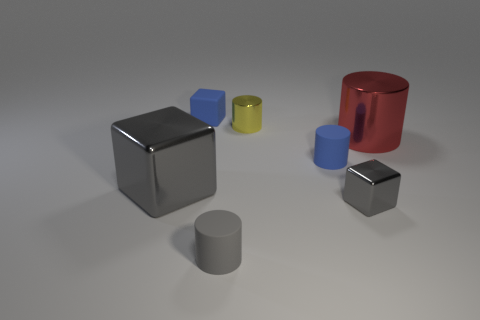What number of other things are the same color as the big shiny cylinder?
Offer a very short reply. 0. Are there fewer tiny gray cubes than large cyan cylinders?
Provide a short and direct response. No. What shape is the tiny blue object in front of the tiny blue object behind the large cylinder?
Ensure brevity in your answer.  Cylinder. Are there any tiny cylinders behind the gray rubber cylinder?
Keep it short and to the point. Yes. There is a matte block that is the same size as the gray rubber cylinder; what color is it?
Your answer should be compact. Blue. How many red things are made of the same material as the blue block?
Your answer should be compact. 0. How many other objects are the same size as the yellow shiny cylinder?
Your response must be concise. 4. Are there any gray shiny objects of the same size as the red object?
Your answer should be very brief. Yes. Is the color of the large shiny object that is to the left of the tiny metal cube the same as the tiny shiny block?
Provide a succinct answer. Yes. How many things are either metal cubes or big red cylinders?
Provide a succinct answer. 3. 